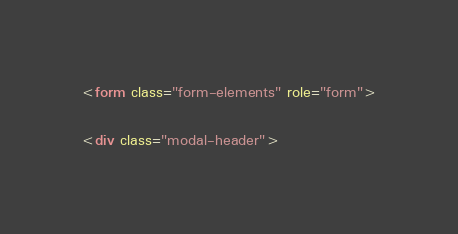<code> <loc_0><loc_0><loc_500><loc_500><_HTML_>
<form class="form-elements" role="form">

<div class="modal-header"></code> 